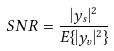<formula> <loc_0><loc_0><loc_500><loc_500>S N R = \frac { | y _ { s } | ^ { 2 } } { E \{ | y _ { v } | ^ { 2 } \} }</formula> 